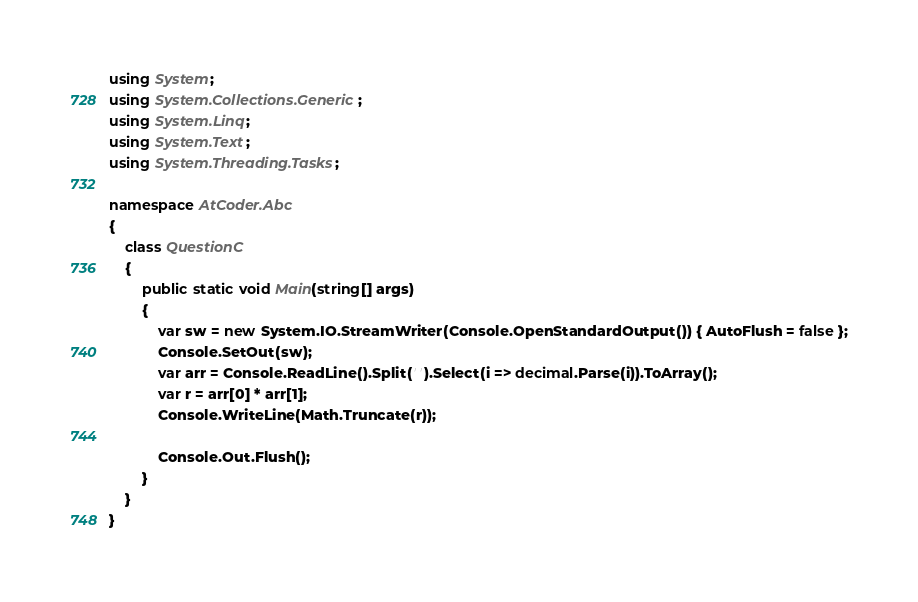<code> <loc_0><loc_0><loc_500><loc_500><_C#_>using System;
using System.Collections.Generic;
using System.Linq;
using System.Text;
using System.Threading.Tasks;

namespace AtCoder.Abc
{
    class QuestionC
    {
        public static void Main(string[] args)
        {
            var sw = new System.IO.StreamWriter(Console.OpenStandardOutput()) { AutoFlush = false };
            Console.SetOut(sw);
            var arr = Console.ReadLine().Split(' ').Select(i => decimal.Parse(i)).ToArray();
            var r = arr[0] * arr[1];
            Console.WriteLine(Math.Truncate(r));

            Console.Out.Flush();
        }
    }
}
</code> 